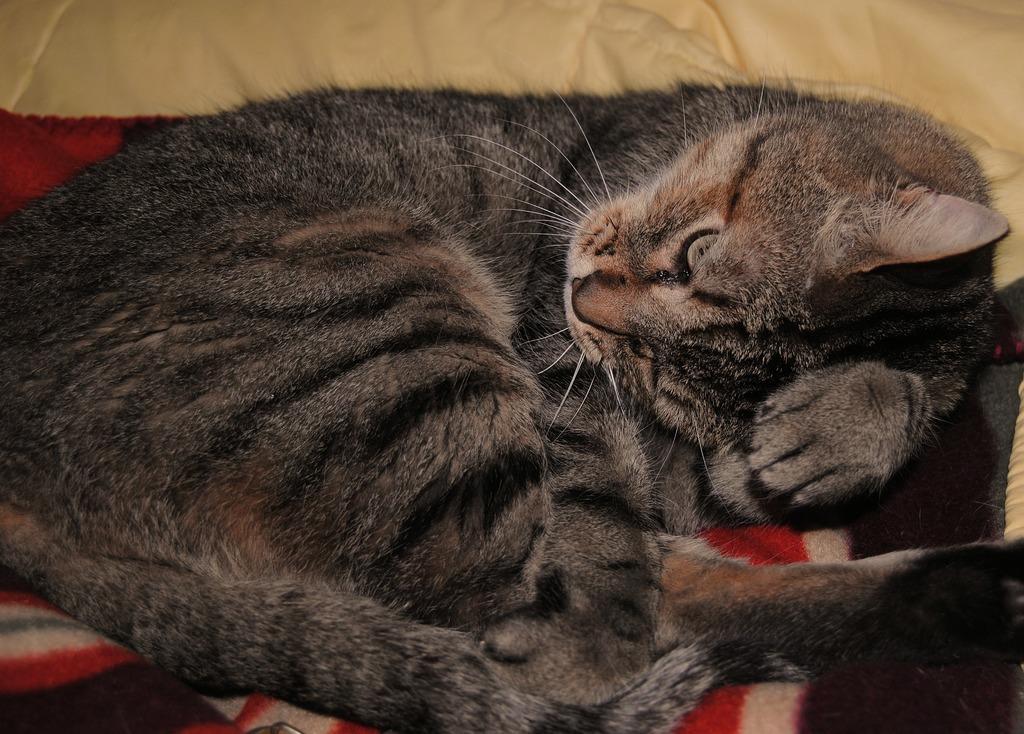Describe this image in one or two sentences. In this image there is a cat sleeping on the couch. 